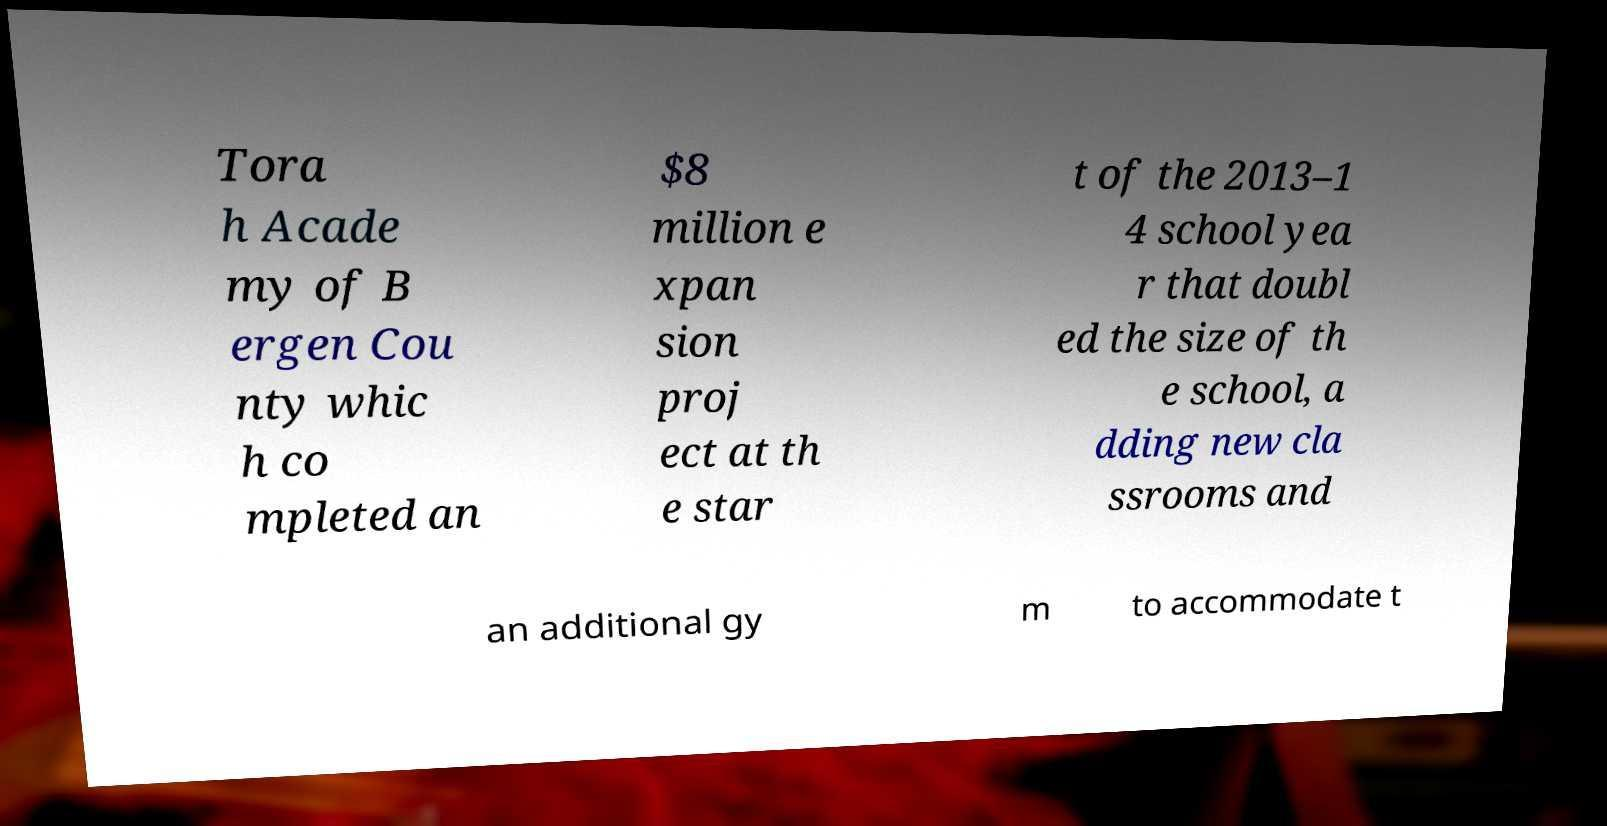Can you read and provide the text displayed in the image?This photo seems to have some interesting text. Can you extract and type it out for me? Tora h Acade my of B ergen Cou nty whic h co mpleted an $8 million e xpan sion proj ect at th e star t of the 2013–1 4 school yea r that doubl ed the size of th e school, a dding new cla ssrooms and an additional gy m to accommodate t 